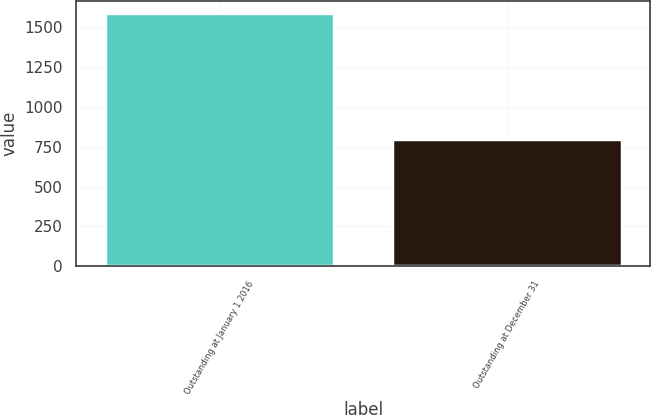Convert chart. <chart><loc_0><loc_0><loc_500><loc_500><bar_chart><fcel>Outstanding at January 1 2016<fcel>Outstanding at December 31<nl><fcel>1586<fcel>796<nl></chart> 